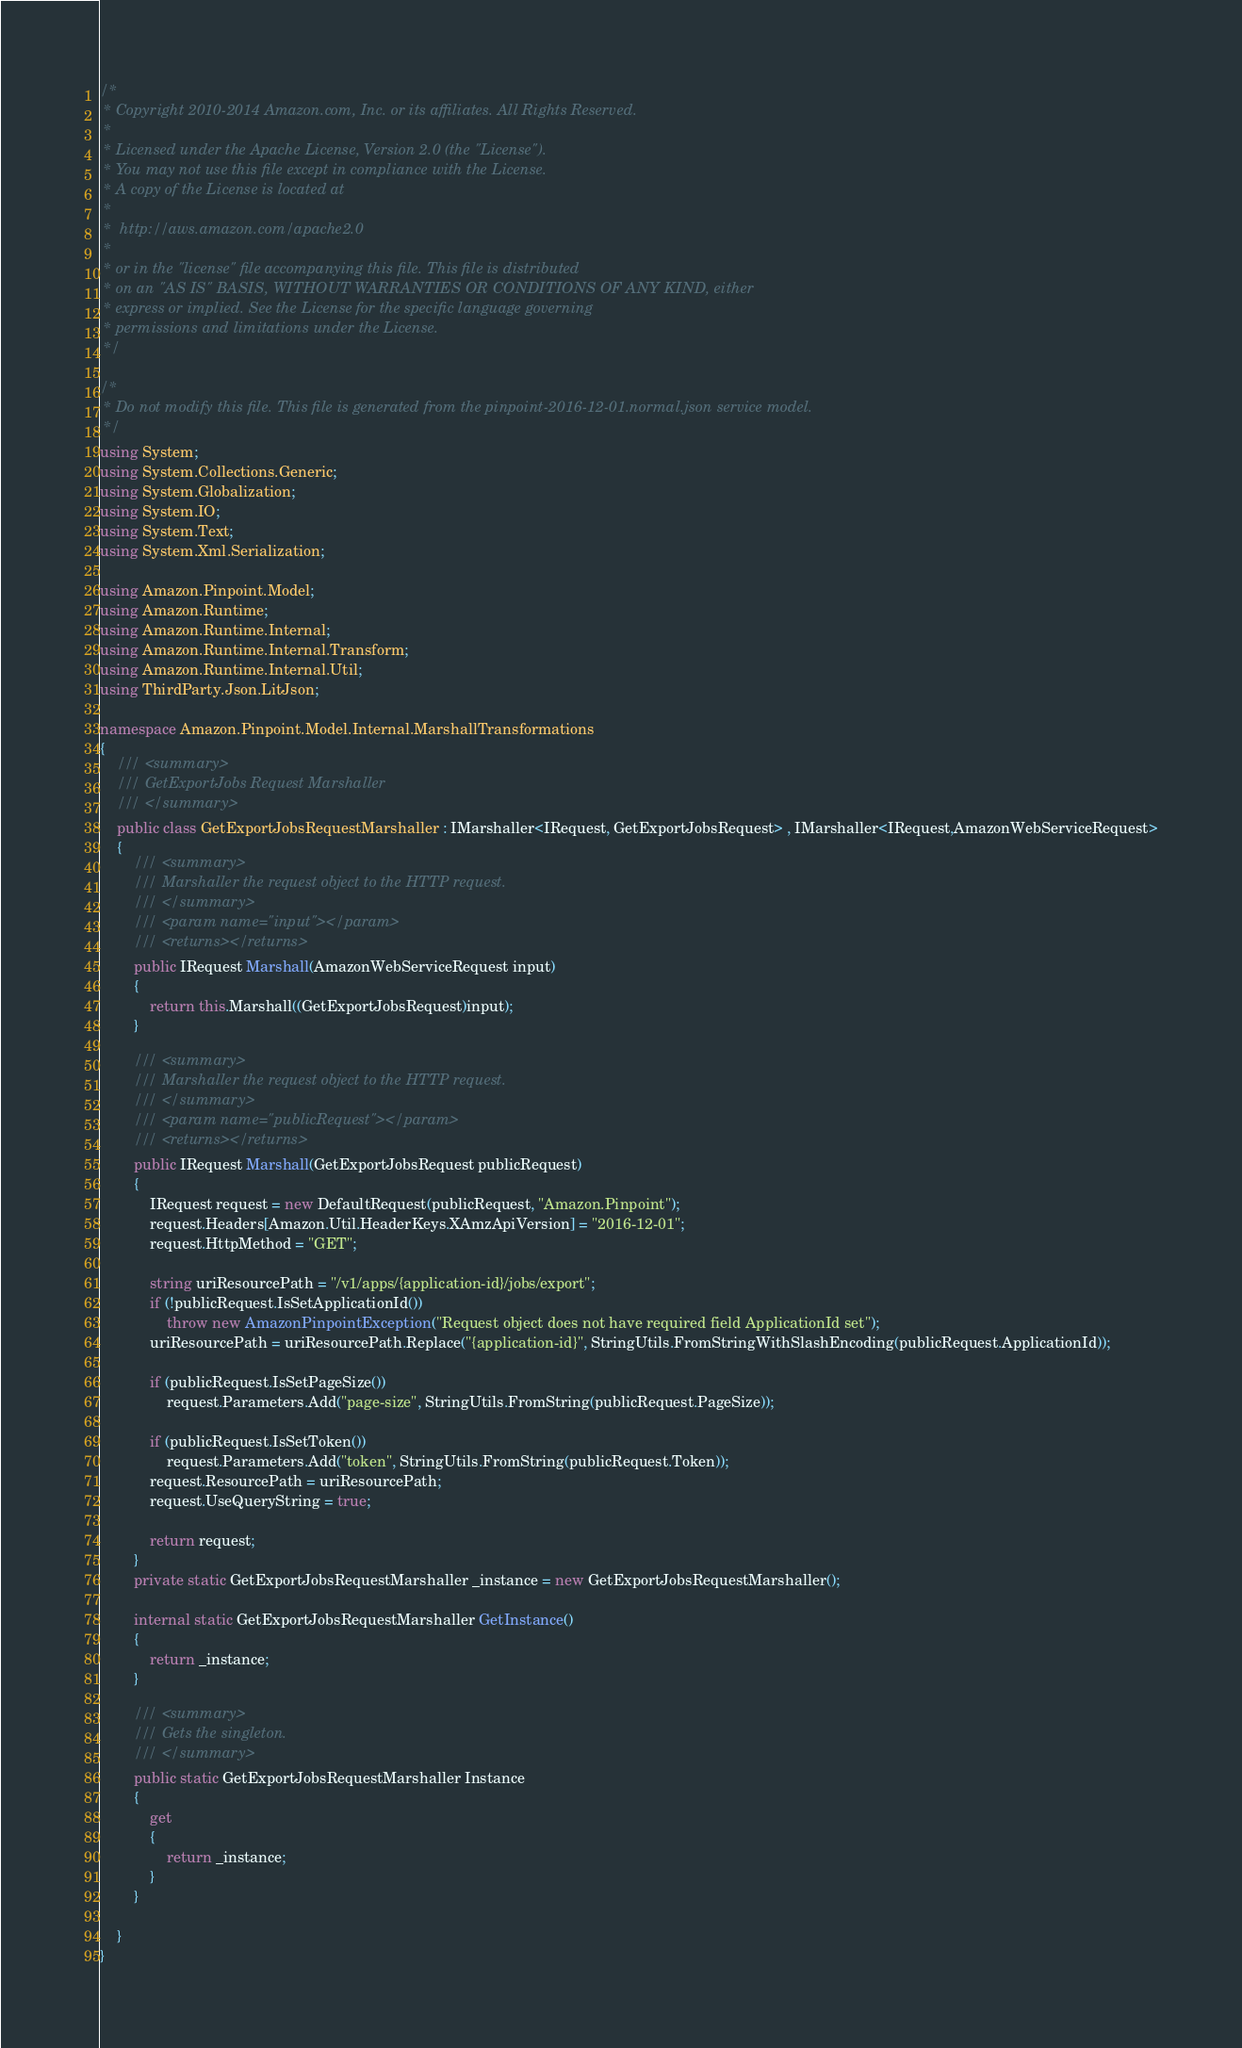<code> <loc_0><loc_0><loc_500><loc_500><_C#_>/*
 * Copyright 2010-2014 Amazon.com, Inc. or its affiliates. All Rights Reserved.
 * 
 * Licensed under the Apache License, Version 2.0 (the "License").
 * You may not use this file except in compliance with the License.
 * A copy of the License is located at
 * 
 *  http://aws.amazon.com/apache2.0
 * 
 * or in the "license" file accompanying this file. This file is distributed
 * on an "AS IS" BASIS, WITHOUT WARRANTIES OR CONDITIONS OF ANY KIND, either
 * express or implied. See the License for the specific language governing
 * permissions and limitations under the License.
 */

/*
 * Do not modify this file. This file is generated from the pinpoint-2016-12-01.normal.json service model.
 */
using System;
using System.Collections.Generic;
using System.Globalization;
using System.IO;
using System.Text;
using System.Xml.Serialization;

using Amazon.Pinpoint.Model;
using Amazon.Runtime;
using Amazon.Runtime.Internal;
using Amazon.Runtime.Internal.Transform;
using Amazon.Runtime.Internal.Util;
using ThirdParty.Json.LitJson;

namespace Amazon.Pinpoint.Model.Internal.MarshallTransformations
{
    /// <summary>
    /// GetExportJobs Request Marshaller
    /// </summary>       
    public class GetExportJobsRequestMarshaller : IMarshaller<IRequest, GetExportJobsRequest> , IMarshaller<IRequest,AmazonWebServiceRequest>
    {
        /// <summary>
        /// Marshaller the request object to the HTTP request.
        /// </summary>  
        /// <param name="input"></param>
        /// <returns></returns>
        public IRequest Marshall(AmazonWebServiceRequest input)
        {
            return this.Marshall((GetExportJobsRequest)input);
        }

        /// <summary>
        /// Marshaller the request object to the HTTP request.
        /// </summary>  
        /// <param name="publicRequest"></param>
        /// <returns></returns>
        public IRequest Marshall(GetExportJobsRequest publicRequest)
        {
            IRequest request = new DefaultRequest(publicRequest, "Amazon.Pinpoint");
            request.Headers[Amazon.Util.HeaderKeys.XAmzApiVersion] = "2016-12-01";            
            request.HttpMethod = "GET";

            string uriResourcePath = "/v1/apps/{application-id}/jobs/export";
            if (!publicRequest.IsSetApplicationId())
                throw new AmazonPinpointException("Request object does not have required field ApplicationId set");
            uriResourcePath = uriResourcePath.Replace("{application-id}", StringUtils.FromStringWithSlashEncoding(publicRequest.ApplicationId));
            
            if (publicRequest.IsSetPageSize())
                request.Parameters.Add("page-size", StringUtils.FromString(publicRequest.PageSize));
            
            if (publicRequest.IsSetToken())
                request.Parameters.Add("token", StringUtils.FromString(publicRequest.Token));
            request.ResourcePath = uriResourcePath;
            request.UseQueryString = true;

            return request;
        }
        private static GetExportJobsRequestMarshaller _instance = new GetExportJobsRequestMarshaller();        

        internal static GetExportJobsRequestMarshaller GetInstance()
        {
            return _instance;
        }

        /// <summary>
        /// Gets the singleton.
        /// </summary>  
        public static GetExportJobsRequestMarshaller Instance
        {
            get
            {
                return _instance;
            }
        }

    }
}</code> 